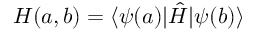<formula> <loc_0><loc_0><loc_500><loc_500>H ( a , b ) = \langle \psi ( a ) | \hat { H } | \psi ( b ) \rangle</formula> 